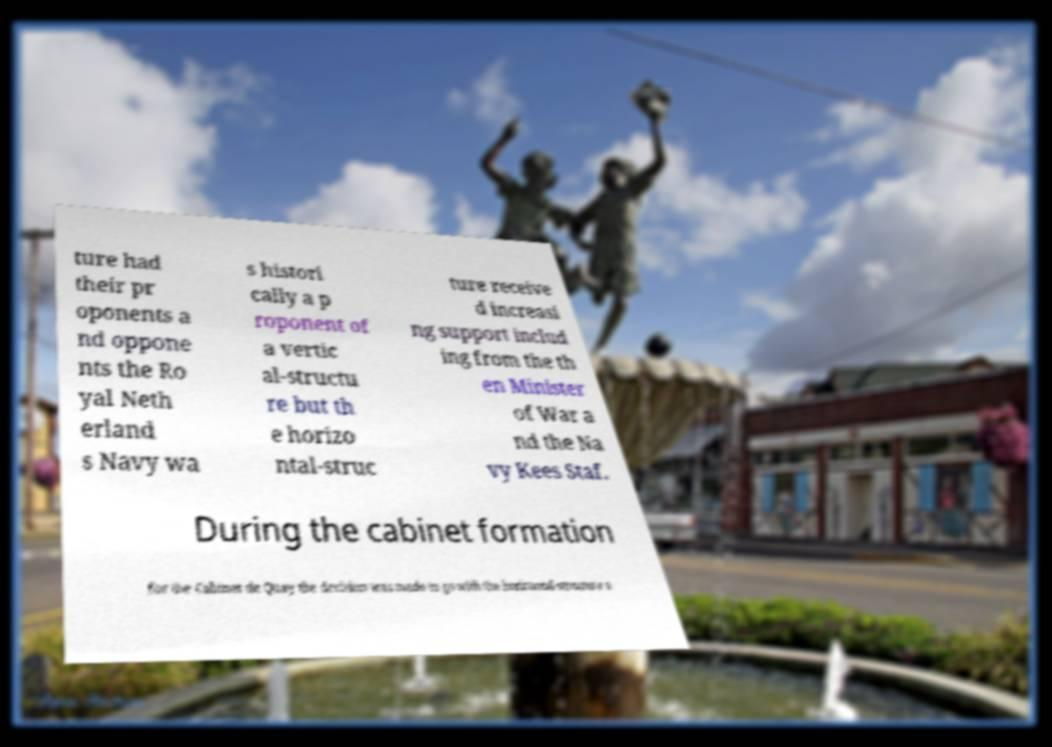For documentation purposes, I need the text within this image transcribed. Could you provide that? ture had their pr oponents a nd oppone nts the Ro yal Neth erland s Navy wa s histori cally a p roponent of a vertic al-structu re but th e horizo ntal-struc ture receive d increasi ng support includ ing from the th en Minister of War a nd the Na vy Kees Staf. During the cabinet formation for the Cabinet de Quay the decision was made to go with the horizontal-structure a 